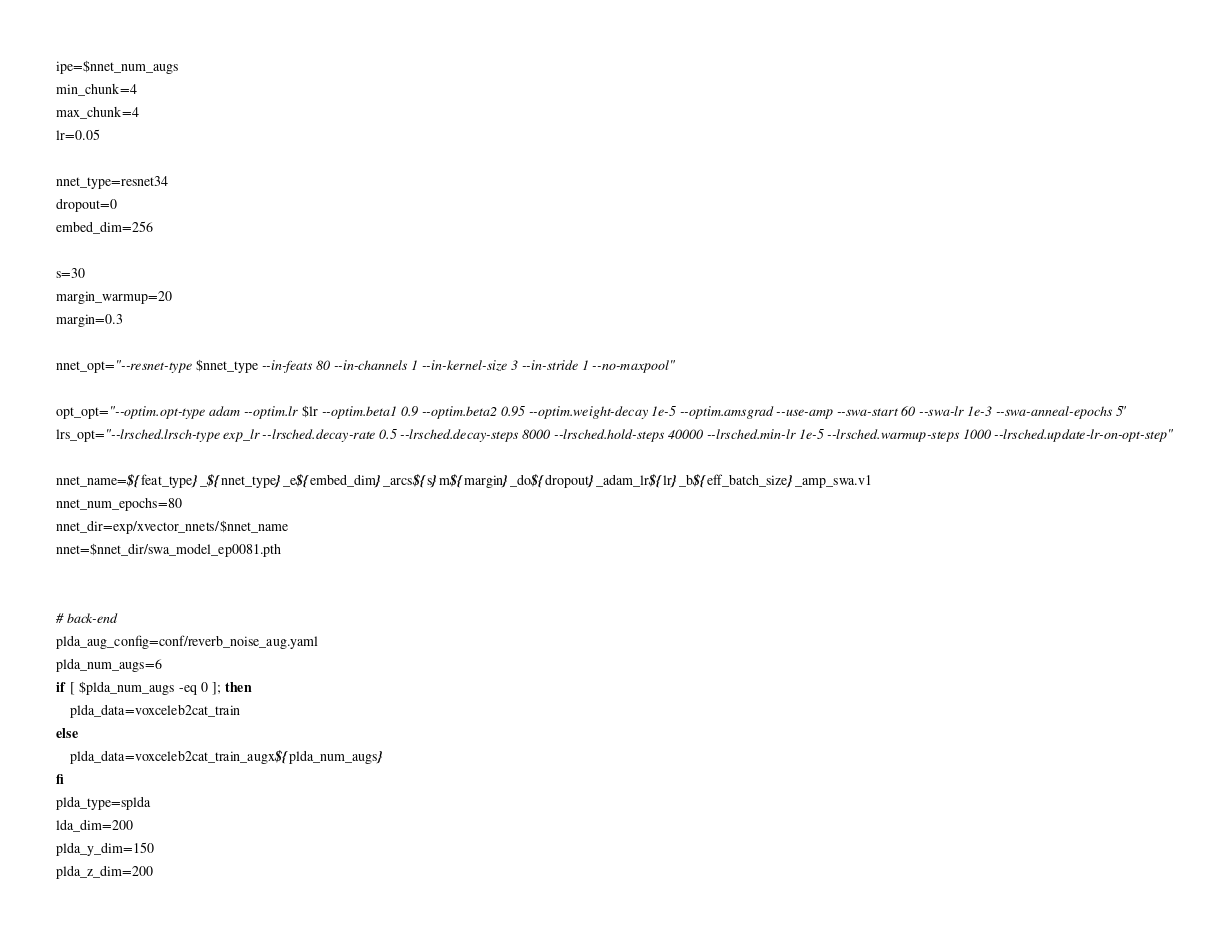Convert code to text. <code><loc_0><loc_0><loc_500><loc_500><_Bash_>ipe=$nnet_num_augs
min_chunk=4
max_chunk=4
lr=0.05

nnet_type=resnet34 
dropout=0
embed_dim=256

s=30
margin_warmup=20
margin=0.3

nnet_opt="--resnet-type $nnet_type --in-feats 80 --in-channels 1 --in-kernel-size 3 --in-stride 1 --no-maxpool"

opt_opt="--optim.opt-type adam --optim.lr $lr --optim.beta1 0.9 --optim.beta2 0.95 --optim.weight-decay 1e-5 --optim.amsgrad --use-amp --swa-start 60 --swa-lr 1e-3 --swa-anneal-epochs 5"
lrs_opt="--lrsched.lrsch-type exp_lr --lrsched.decay-rate 0.5 --lrsched.decay-steps 8000 --lrsched.hold-steps 40000 --lrsched.min-lr 1e-5 --lrsched.warmup-steps 1000 --lrsched.update-lr-on-opt-step"

nnet_name=${feat_type}_${nnet_type}_e${embed_dim}_arcs${s}m${margin}_do${dropout}_adam_lr${lr}_b${eff_batch_size}_amp_swa.v1
nnet_num_epochs=80
nnet_dir=exp/xvector_nnets/$nnet_name
nnet=$nnet_dir/swa_model_ep0081.pth


# back-end
plda_aug_config=conf/reverb_noise_aug.yaml
plda_num_augs=6
if [ $plda_num_augs -eq 0 ]; then
    plda_data=voxceleb2cat_train
else
    plda_data=voxceleb2cat_train_augx${plda_num_augs}
fi
plda_type=splda
lda_dim=200
plda_y_dim=150
plda_z_dim=200

</code> 